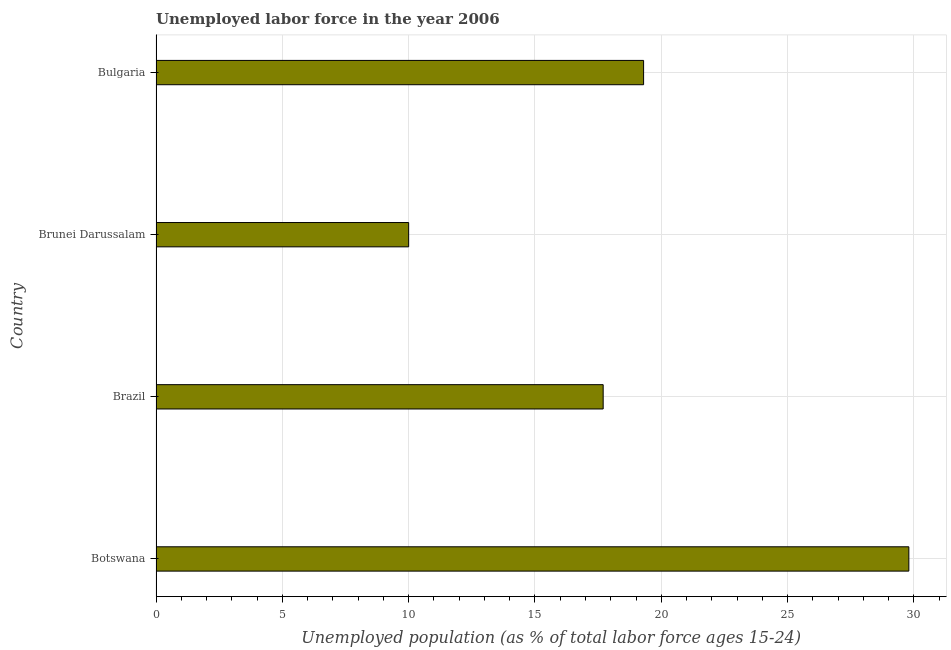Does the graph contain any zero values?
Keep it short and to the point. No. What is the title of the graph?
Make the answer very short. Unemployed labor force in the year 2006. What is the label or title of the X-axis?
Provide a succinct answer. Unemployed population (as % of total labor force ages 15-24). What is the total unemployed youth population in Bulgaria?
Make the answer very short. 19.3. Across all countries, what is the maximum total unemployed youth population?
Your answer should be very brief. 29.8. In which country was the total unemployed youth population maximum?
Offer a very short reply. Botswana. In which country was the total unemployed youth population minimum?
Offer a very short reply. Brunei Darussalam. What is the sum of the total unemployed youth population?
Your answer should be very brief. 76.8. What is the average total unemployed youth population per country?
Provide a short and direct response. 19.2. In how many countries, is the total unemployed youth population greater than 13 %?
Offer a terse response. 3. What is the ratio of the total unemployed youth population in Botswana to that in Brazil?
Make the answer very short. 1.68. Is the total unemployed youth population in Brunei Darussalam less than that in Bulgaria?
Offer a terse response. Yes. Is the difference between the total unemployed youth population in Botswana and Brunei Darussalam greater than the difference between any two countries?
Provide a short and direct response. Yes. What is the difference between the highest and the second highest total unemployed youth population?
Give a very brief answer. 10.5. Is the sum of the total unemployed youth population in Brunei Darussalam and Bulgaria greater than the maximum total unemployed youth population across all countries?
Keep it short and to the point. No. What is the difference between the highest and the lowest total unemployed youth population?
Make the answer very short. 19.8. How many bars are there?
Provide a short and direct response. 4. Are the values on the major ticks of X-axis written in scientific E-notation?
Ensure brevity in your answer.  No. What is the Unemployed population (as % of total labor force ages 15-24) in Botswana?
Ensure brevity in your answer.  29.8. What is the Unemployed population (as % of total labor force ages 15-24) of Brazil?
Provide a succinct answer. 17.7. What is the Unemployed population (as % of total labor force ages 15-24) in Bulgaria?
Keep it short and to the point. 19.3. What is the difference between the Unemployed population (as % of total labor force ages 15-24) in Botswana and Brunei Darussalam?
Your answer should be very brief. 19.8. What is the difference between the Unemployed population (as % of total labor force ages 15-24) in Botswana and Bulgaria?
Provide a short and direct response. 10.5. What is the difference between the Unemployed population (as % of total labor force ages 15-24) in Brazil and Brunei Darussalam?
Offer a terse response. 7.7. What is the difference between the Unemployed population (as % of total labor force ages 15-24) in Brunei Darussalam and Bulgaria?
Make the answer very short. -9.3. What is the ratio of the Unemployed population (as % of total labor force ages 15-24) in Botswana to that in Brazil?
Ensure brevity in your answer.  1.68. What is the ratio of the Unemployed population (as % of total labor force ages 15-24) in Botswana to that in Brunei Darussalam?
Offer a terse response. 2.98. What is the ratio of the Unemployed population (as % of total labor force ages 15-24) in Botswana to that in Bulgaria?
Your response must be concise. 1.54. What is the ratio of the Unemployed population (as % of total labor force ages 15-24) in Brazil to that in Brunei Darussalam?
Offer a very short reply. 1.77. What is the ratio of the Unemployed population (as % of total labor force ages 15-24) in Brazil to that in Bulgaria?
Give a very brief answer. 0.92. What is the ratio of the Unemployed population (as % of total labor force ages 15-24) in Brunei Darussalam to that in Bulgaria?
Your response must be concise. 0.52. 